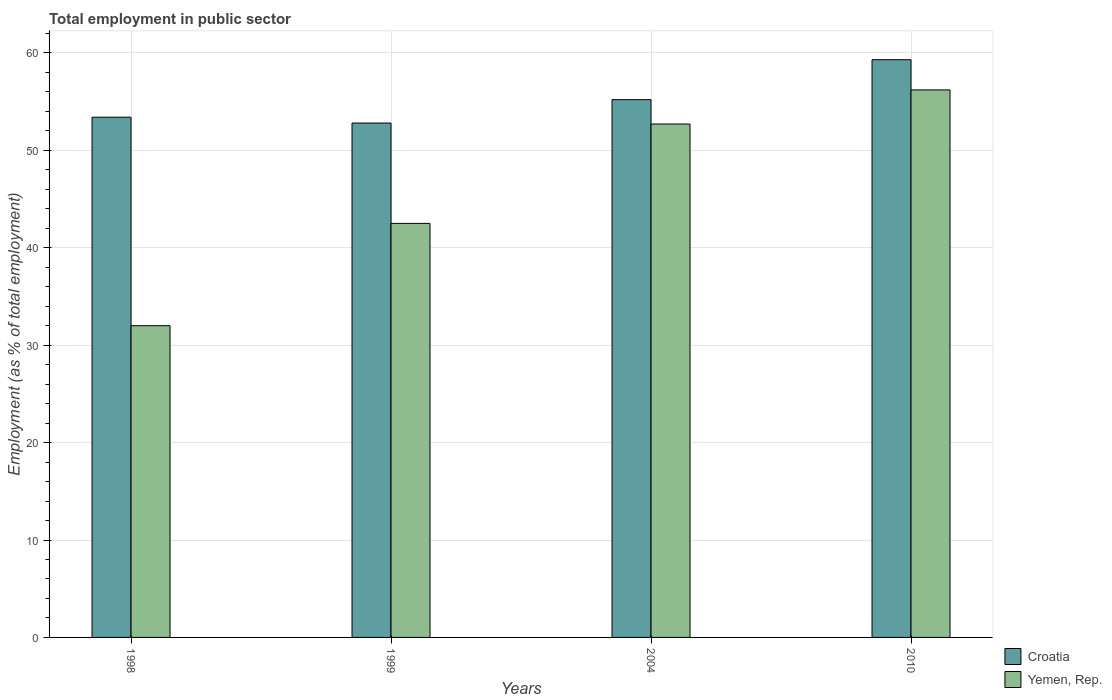How many different coloured bars are there?
Ensure brevity in your answer.  2. How many groups of bars are there?
Your answer should be compact. 4. Are the number of bars per tick equal to the number of legend labels?
Give a very brief answer. Yes. Are the number of bars on each tick of the X-axis equal?
Offer a terse response. Yes. How many bars are there on the 2nd tick from the left?
Your answer should be very brief. 2. How many bars are there on the 2nd tick from the right?
Your answer should be very brief. 2. What is the label of the 2nd group of bars from the left?
Make the answer very short. 1999. In how many cases, is the number of bars for a given year not equal to the number of legend labels?
Offer a terse response. 0. What is the employment in public sector in Croatia in 2010?
Provide a short and direct response. 59.3. Across all years, what is the maximum employment in public sector in Croatia?
Offer a very short reply. 59.3. In which year was the employment in public sector in Yemen, Rep. maximum?
Offer a very short reply. 2010. In which year was the employment in public sector in Croatia minimum?
Offer a terse response. 1999. What is the total employment in public sector in Yemen, Rep. in the graph?
Give a very brief answer. 183.4. What is the difference between the employment in public sector in Yemen, Rep. in 1998 and that in 2004?
Make the answer very short. -20.7. What is the difference between the employment in public sector in Yemen, Rep. in 2010 and the employment in public sector in Croatia in 2004?
Your answer should be compact. 1. What is the average employment in public sector in Croatia per year?
Provide a short and direct response. 55.18. In the year 2004, what is the difference between the employment in public sector in Yemen, Rep. and employment in public sector in Croatia?
Provide a succinct answer. -2.5. What is the ratio of the employment in public sector in Yemen, Rep. in 2004 to that in 2010?
Provide a short and direct response. 0.94. Is the employment in public sector in Yemen, Rep. in 1998 less than that in 2004?
Your answer should be very brief. Yes. What is the difference between the highest and the second highest employment in public sector in Croatia?
Your response must be concise. 4.1. In how many years, is the employment in public sector in Croatia greater than the average employment in public sector in Croatia taken over all years?
Make the answer very short. 2. What does the 2nd bar from the left in 1999 represents?
Provide a short and direct response. Yemen, Rep. What does the 2nd bar from the right in 1999 represents?
Make the answer very short. Croatia. How many years are there in the graph?
Provide a succinct answer. 4. What is the difference between two consecutive major ticks on the Y-axis?
Provide a short and direct response. 10. Does the graph contain any zero values?
Your answer should be compact. No. Where does the legend appear in the graph?
Keep it short and to the point. Bottom right. How are the legend labels stacked?
Ensure brevity in your answer.  Vertical. What is the title of the graph?
Provide a succinct answer. Total employment in public sector. Does "Pakistan" appear as one of the legend labels in the graph?
Offer a terse response. No. What is the label or title of the X-axis?
Give a very brief answer. Years. What is the label or title of the Y-axis?
Keep it short and to the point. Employment (as % of total employment). What is the Employment (as % of total employment) in Croatia in 1998?
Offer a very short reply. 53.4. What is the Employment (as % of total employment) in Croatia in 1999?
Your response must be concise. 52.8. What is the Employment (as % of total employment) of Yemen, Rep. in 1999?
Keep it short and to the point. 42.5. What is the Employment (as % of total employment) in Croatia in 2004?
Keep it short and to the point. 55.2. What is the Employment (as % of total employment) in Yemen, Rep. in 2004?
Keep it short and to the point. 52.7. What is the Employment (as % of total employment) of Croatia in 2010?
Ensure brevity in your answer.  59.3. What is the Employment (as % of total employment) of Yemen, Rep. in 2010?
Provide a succinct answer. 56.2. Across all years, what is the maximum Employment (as % of total employment) in Croatia?
Make the answer very short. 59.3. Across all years, what is the maximum Employment (as % of total employment) in Yemen, Rep.?
Keep it short and to the point. 56.2. Across all years, what is the minimum Employment (as % of total employment) of Croatia?
Your answer should be very brief. 52.8. Across all years, what is the minimum Employment (as % of total employment) in Yemen, Rep.?
Give a very brief answer. 32. What is the total Employment (as % of total employment) in Croatia in the graph?
Provide a succinct answer. 220.7. What is the total Employment (as % of total employment) of Yemen, Rep. in the graph?
Offer a very short reply. 183.4. What is the difference between the Employment (as % of total employment) in Croatia in 1998 and that in 1999?
Your answer should be compact. 0.6. What is the difference between the Employment (as % of total employment) of Yemen, Rep. in 1998 and that in 2004?
Ensure brevity in your answer.  -20.7. What is the difference between the Employment (as % of total employment) of Croatia in 1998 and that in 2010?
Make the answer very short. -5.9. What is the difference between the Employment (as % of total employment) in Yemen, Rep. in 1998 and that in 2010?
Your response must be concise. -24.2. What is the difference between the Employment (as % of total employment) in Yemen, Rep. in 1999 and that in 2010?
Your answer should be very brief. -13.7. What is the difference between the Employment (as % of total employment) in Croatia in 2004 and that in 2010?
Offer a very short reply. -4.1. What is the difference between the Employment (as % of total employment) of Croatia in 1999 and the Employment (as % of total employment) of Yemen, Rep. in 2010?
Keep it short and to the point. -3.4. What is the difference between the Employment (as % of total employment) in Croatia in 2004 and the Employment (as % of total employment) in Yemen, Rep. in 2010?
Provide a short and direct response. -1. What is the average Employment (as % of total employment) of Croatia per year?
Provide a short and direct response. 55.17. What is the average Employment (as % of total employment) in Yemen, Rep. per year?
Offer a very short reply. 45.85. In the year 1998, what is the difference between the Employment (as % of total employment) of Croatia and Employment (as % of total employment) of Yemen, Rep.?
Your response must be concise. 21.4. What is the ratio of the Employment (as % of total employment) in Croatia in 1998 to that in 1999?
Your answer should be very brief. 1.01. What is the ratio of the Employment (as % of total employment) in Yemen, Rep. in 1998 to that in 1999?
Give a very brief answer. 0.75. What is the ratio of the Employment (as % of total employment) of Croatia in 1998 to that in 2004?
Offer a terse response. 0.97. What is the ratio of the Employment (as % of total employment) in Yemen, Rep. in 1998 to that in 2004?
Make the answer very short. 0.61. What is the ratio of the Employment (as % of total employment) in Croatia in 1998 to that in 2010?
Give a very brief answer. 0.9. What is the ratio of the Employment (as % of total employment) in Yemen, Rep. in 1998 to that in 2010?
Make the answer very short. 0.57. What is the ratio of the Employment (as % of total employment) in Croatia in 1999 to that in 2004?
Give a very brief answer. 0.96. What is the ratio of the Employment (as % of total employment) of Yemen, Rep. in 1999 to that in 2004?
Ensure brevity in your answer.  0.81. What is the ratio of the Employment (as % of total employment) of Croatia in 1999 to that in 2010?
Give a very brief answer. 0.89. What is the ratio of the Employment (as % of total employment) in Yemen, Rep. in 1999 to that in 2010?
Provide a short and direct response. 0.76. What is the ratio of the Employment (as % of total employment) of Croatia in 2004 to that in 2010?
Provide a succinct answer. 0.93. What is the ratio of the Employment (as % of total employment) of Yemen, Rep. in 2004 to that in 2010?
Offer a terse response. 0.94. What is the difference between the highest and the lowest Employment (as % of total employment) of Croatia?
Your answer should be compact. 6.5. What is the difference between the highest and the lowest Employment (as % of total employment) of Yemen, Rep.?
Offer a terse response. 24.2. 